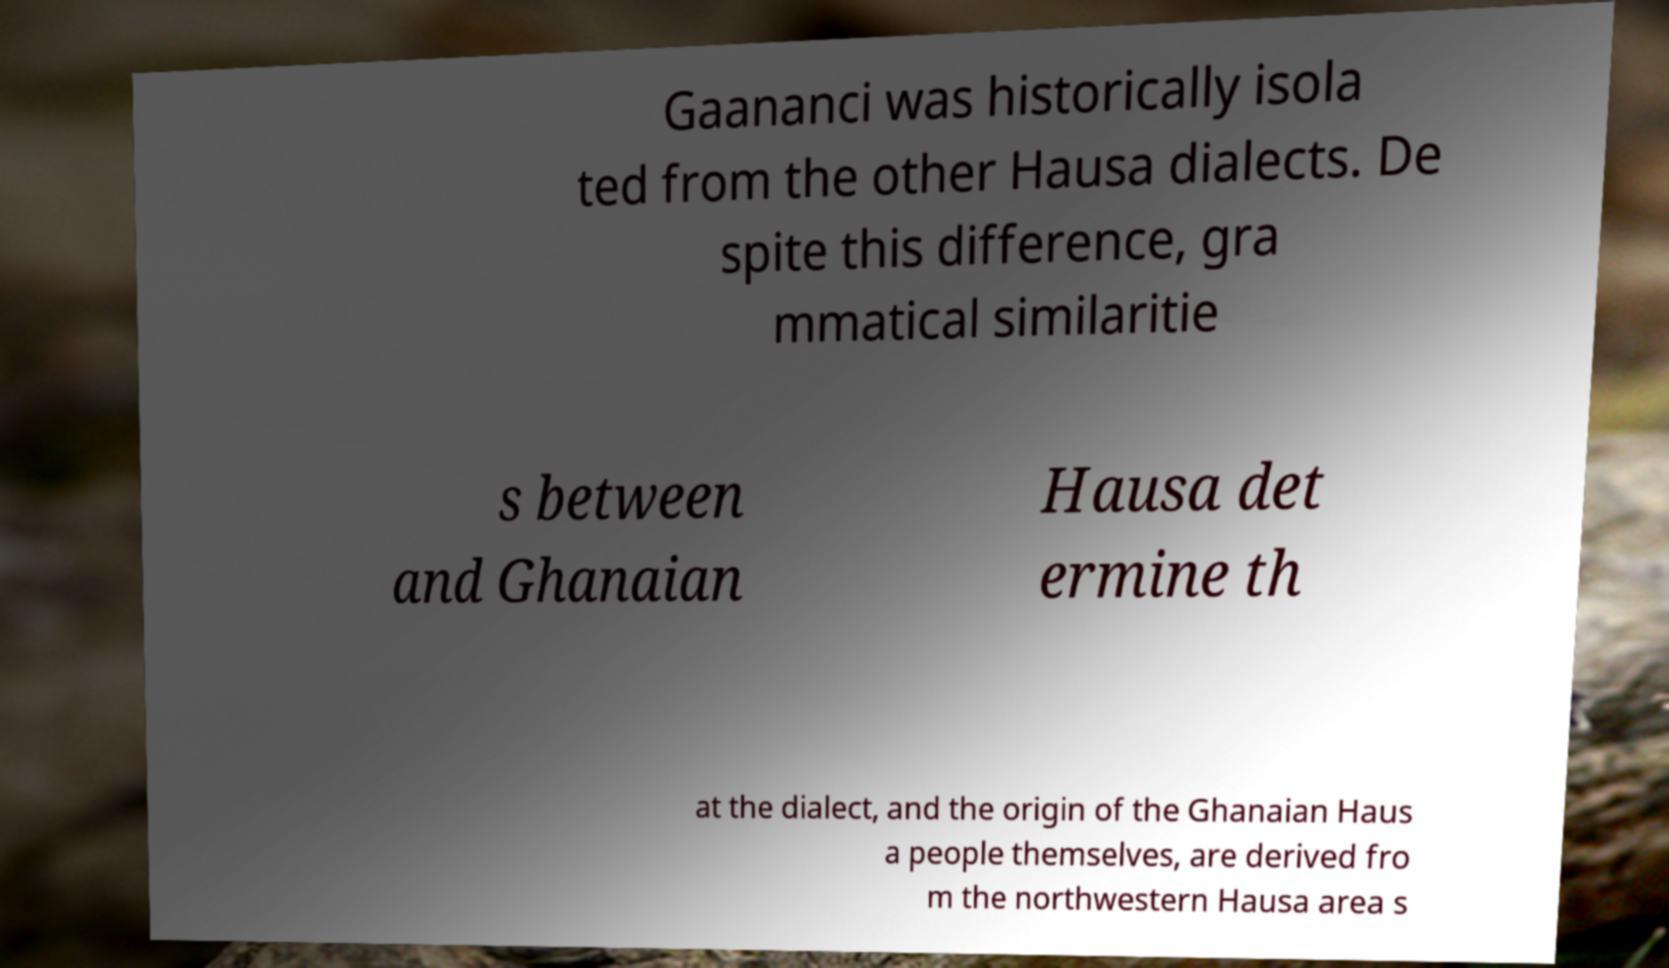I need the written content from this picture converted into text. Can you do that? Gaananci was historically isola ted from the other Hausa dialects. De spite this difference, gra mmatical similaritie s between and Ghanaian Hausa det ermine th at the dialect, and the origin of the Ghanaian Haus a people themselves, are derived fro m the northwestern Hausa area s 